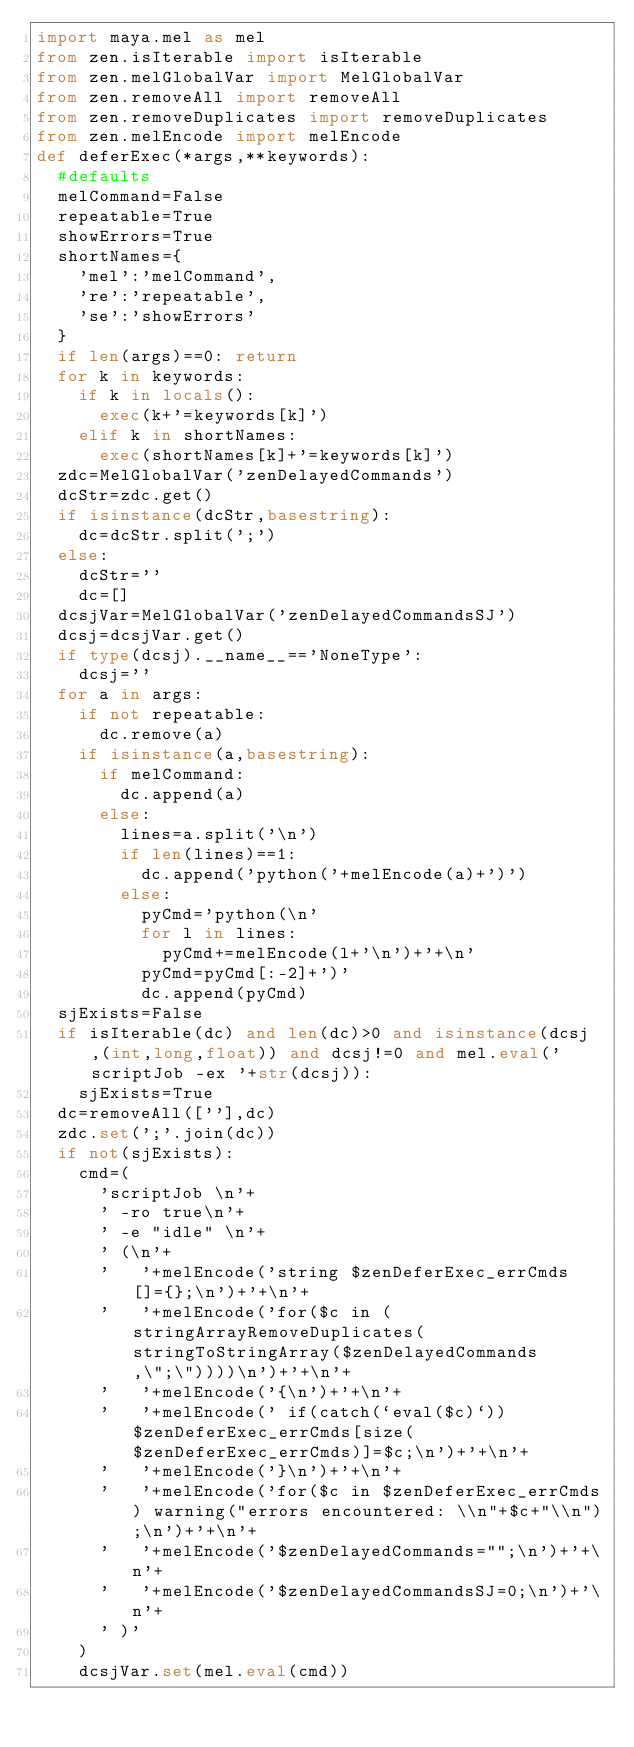<code> <loc_0><loc_0><loc_500><loc_500><_Python_>import maya.mel as mel
from zen.isIterable import isIterable
from zen.melGlobalVar import MelGlobalVar
from zen.removeAll import removeAll
from zen.removeDuplicates import removeDuplicates
from zen.melEncode import melEncode
def deferExec(*args,**keywords):
	#defaults
	melCommand=False
	repeatable=True
	showErrors=True
	shortNames={
		'mel':'melCommand',
		're':'repeatable',
		'se':'showErrors'
	}
	if len(args)==0: return
	for k in keywords:
		if k in locals():
			exec(k+'=keywords[k]')
		elif k in shortNames:
			exec(shortNames[k]+'=keywords[k]')
	zdc=MelGlobalVar('zenDelayedCommands')
	dcStr=zdc.get()
	if isinstance(dcStr,basestring):
		dc=dcStr.split(';')
	else:
		dcStr=''
		dc=[]
	dcsjVar=MelGlobalVar('zenDelayedCommandsSJ')
	dcsj=dcsjVar.get()
	if type(dcsj).__name__=='NoneType':
		dcsj=''
	for a in args:
		if not repeatable:
			dc.remove(a)
		if isinstance(a,basestring):
			if melCommand:
				dc.append(a)
			else:
				lines=a.split('\n')
				if len(lines)==1:
					dc.append('python('+melEncode(a)+')')
				else:
					pyCmd='python(\n'
					for l in lines:
						pyCmd+=melEncode(l+'\n')+'+\n'
					pyCmd=pyCmd[:-2]+')'
					dc.append(pyCmd)
	sjExists=False
	if isIterable(dc) and len(dc)>0 and isinstance(dcsj,(int,long,float)) and dcsj!=0 and mel.eval('scriptJob -ex '+str(dcsj)):
		sjExists=True
	dc=removeAll([''],dc)
	zdc.set(';'.join(dc))
	if not(sjExists):
		cmd=(
			'scriptJob \n'+
			'	-ro true\n'+
			'	-e "idle" \n'+
			'	(\n'+
			'		'+melEncode('string $zenDeferExec_errCmds[]={};\n')+'+\n'+
			'		'+melEncode('for($c in (stringArrayRemoveDuplicates(stringToStringArray($zenDelayedCommands,\";\"))))\n')+'+\n'+
			'		'+melEncode('{\n')+'+\n'+
			'		'+melEncode('	if(catch(`eval($c)`)) $zenDeferExec_errCmds[size($zenDeferExec_errCmds)]=$c;\n')+'+\n'+
			'		'+melEncode('}\n')+'+\n'+
			'		'+melEncode('for($c in $zenDeferExec_errCmds) warning("errors encountered: \\n"+$c+"\\n");\n')+'+\n'+
			'		'+melEncode('$zenDelayedCommands="";\n')+'+\n'+
			'		'+melEncode('$zenDelayedCommandsSJ=0;\n')+'\n'+
			'	)'
		)
		dcsjVar.set(mel.eval(cmd))
</code> 